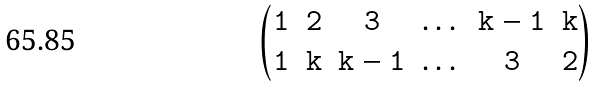Convert formula to latex. <formula><loc_0><loc_0><loc_500><loc_500>\begin{pmatrix} \tt { 1 } & \tt { 2 } & \tt { 3 } & \dots & \tt { k - 1 } & \tt { k } \\ \tt { 1 } & \tt { k } & \tt { k - 1 } & \dots & \tt { 3 } & \tt { 2 } \end{pmatrix}</formula> 